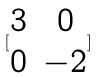<formula> <loc_0><loc_0><loc_500><loc_500>[ \begin{matrix} 3 & 0 \\ 0 & - 2 \end{matrix} ]</formula> 